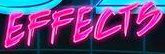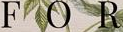What words can you see in these images in sequence, separated by a semicolon? EFFECTS; FOR 